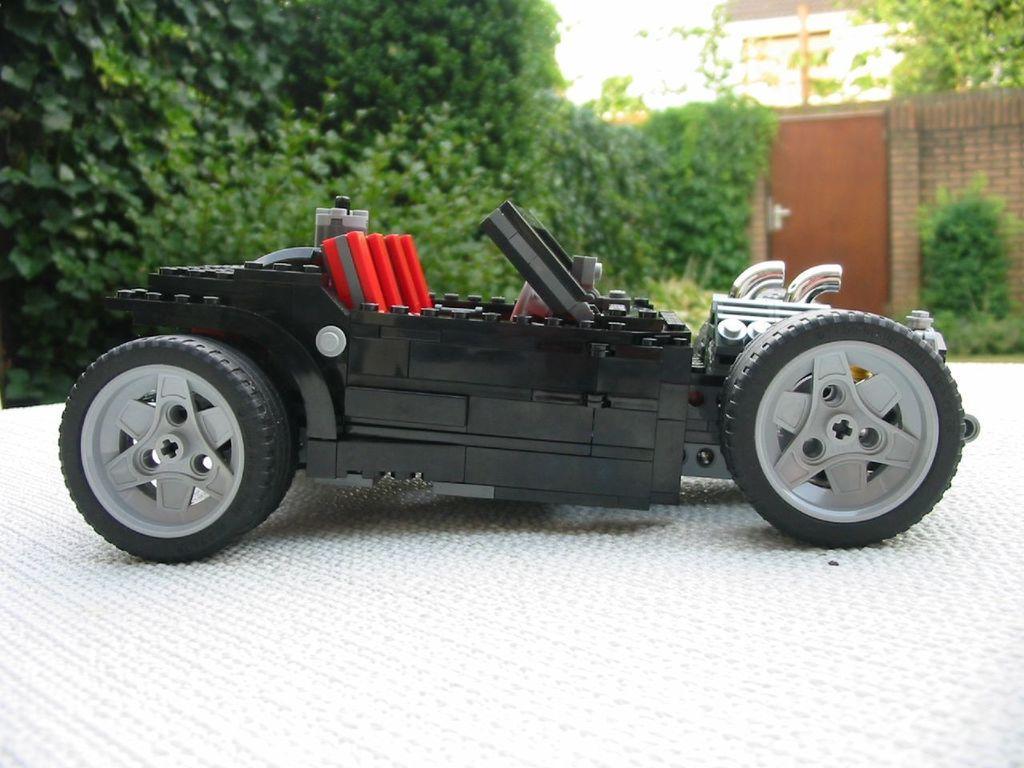Please provide a concise description of this image. In this image we can see a toy car on the white colored surface, there are plants, trees, there is a door, also we can see the wall, and the sky. 